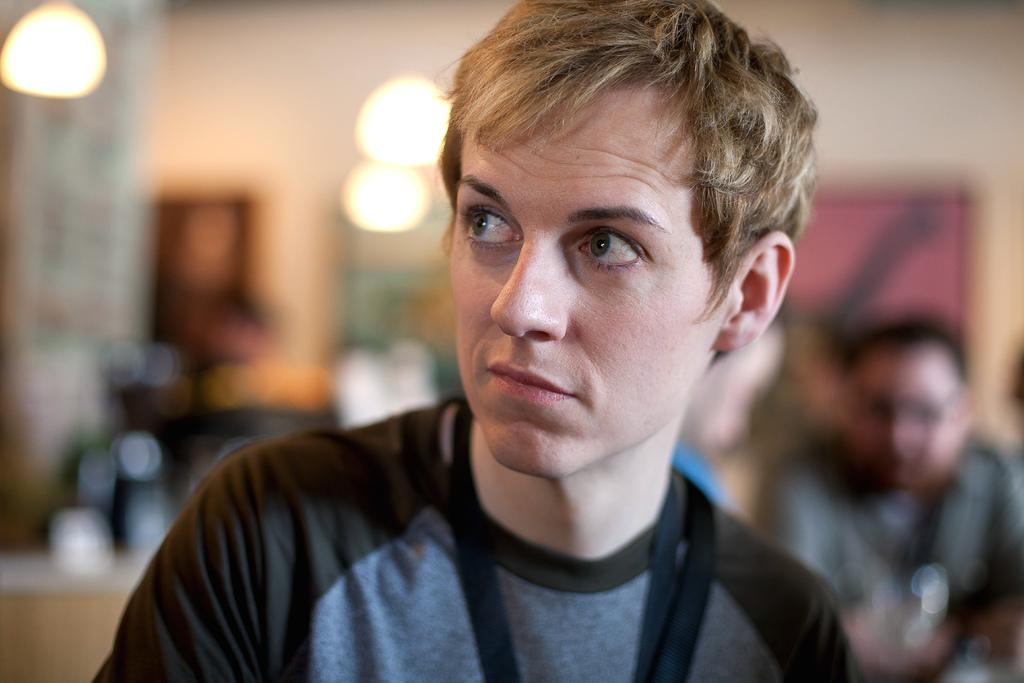What is the main subject of the image? There is a person in the image. Can you describe the background of the image? The background of the image is blurred. Are there any other people visible in the image? Yes, there is another person in the bottom right of the image. What type of music is being played by the person in the image? There is no indication of music or any musical instruments in the image. 